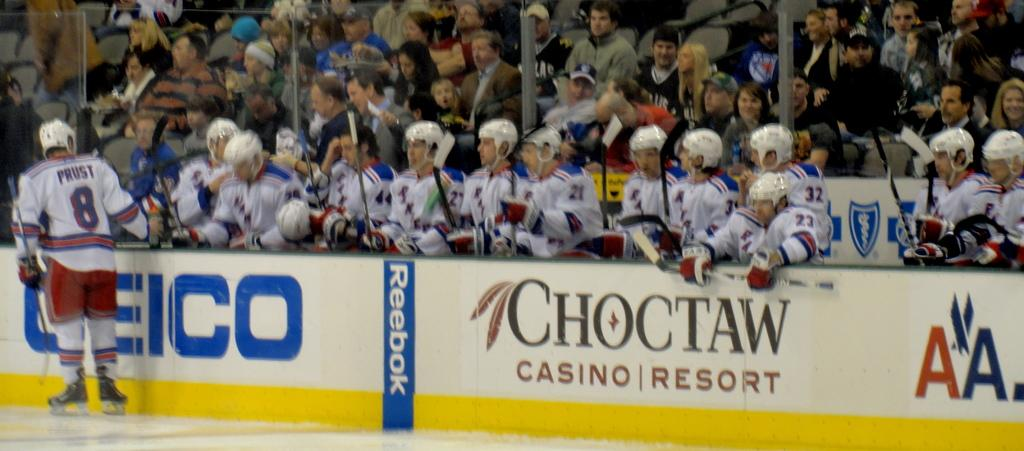<image>
Create a compact narrative representing the image presented. Prost wears number 8 and is on the ice. 